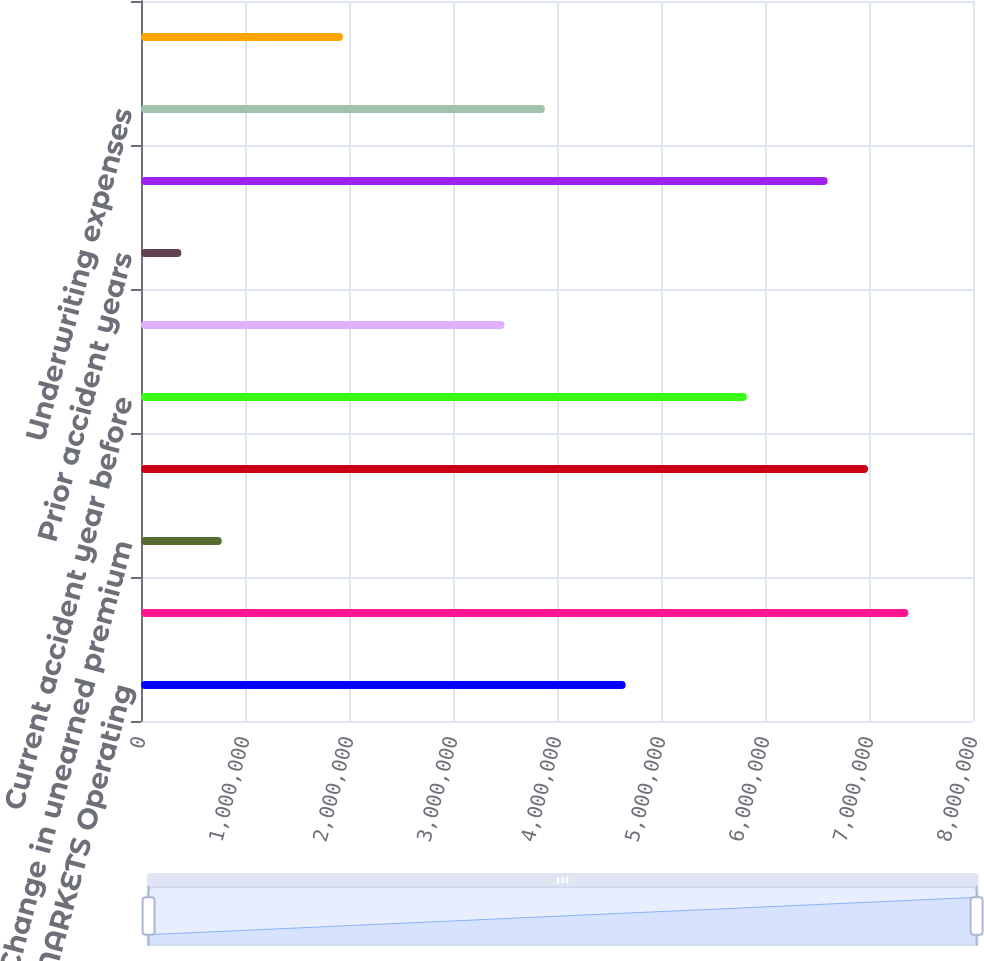<chart> <loc_0><loc_0><loc_500><loc_500><bar_chart><fcel>CONSUMER MARKETS Operating<fcel>Written premiums<fcel>Change in unearned premium<fcel>Earned premiums<fcel>Current accident year before<fcel>Current accident year<fcel>Prior accident years<fcel>Total losses and loss<fcel>Underwriting expenses<fcel>Underwriting results<nl><fcel>4.66059e+06<fcel>7.37925e+06<fcel>776789<fcel>6.99087e+06<fcel>5.82573e+06<fcel>3.49545e+06<fcel>388409<fcel>6.60249e+06<fcel>3.88383e+06<fcel>1.94193e+06<nl></chart> 